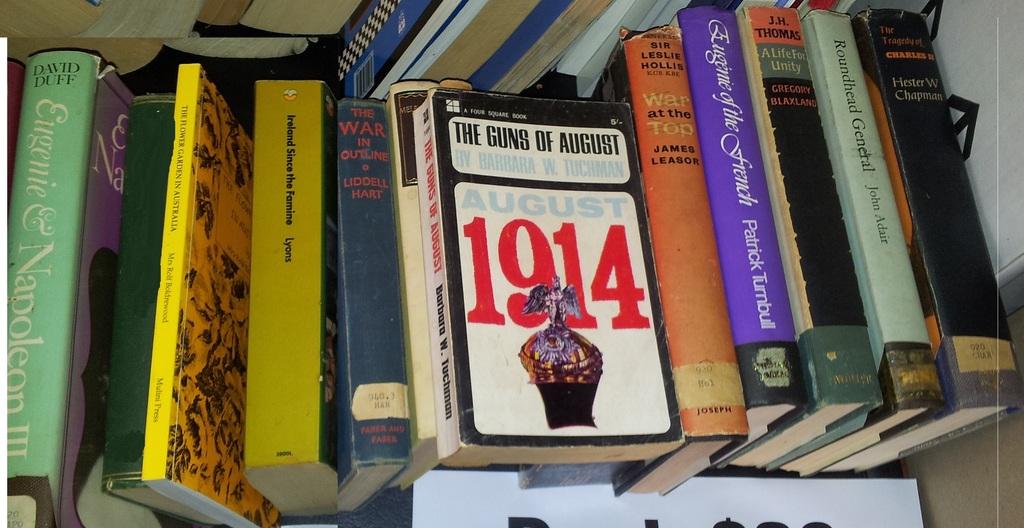What date is mentioned on the cover of the book on the top of the stack?
Provide a short and direct response. 1914. What book did david duff author?
Give a very brief answer. Eugenie & napoleon iii. 